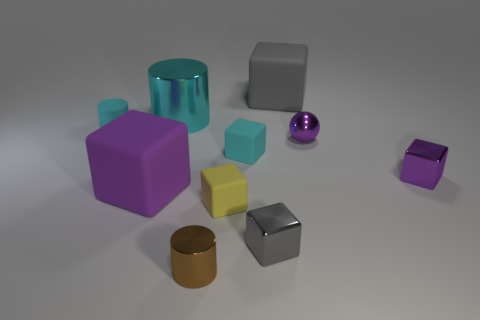What number of brown things are the same shape as the large cyan metal object?
Keep it short and to the point. 1. What is the material of the large cyan cylinder?
Offer a terse response. Metal. Is the number of small cyan rubber things that are behind the large cyan metal cylinder the same as the number of large yellow rubber objects?
Give a very brief answer. Yes. The brown object that is the same size as the ball is what shape?
Provide a succinct answer. Cylinder. Are there any metallic cylinders that are in front of the metallic cube that is in front of the large purple object?
Your answer should be compact. Yes. What number of small things are either cubes or matte cylinders?
Your answer should be compact. 5. Are there any purple shiny balls of the same size as the gray metal block?
Your answer should be compact. Yes. How many shiny objects are big cyan cylinders or small yellow blocks?
Your answer should be very brief. 1. There is a shiny thing that is the same color as the tiny matte cylinder; what is its shape?
Your response must be concise. Cylinder. How many yellow rubber things are there?
Offer a very short reply. 1. 